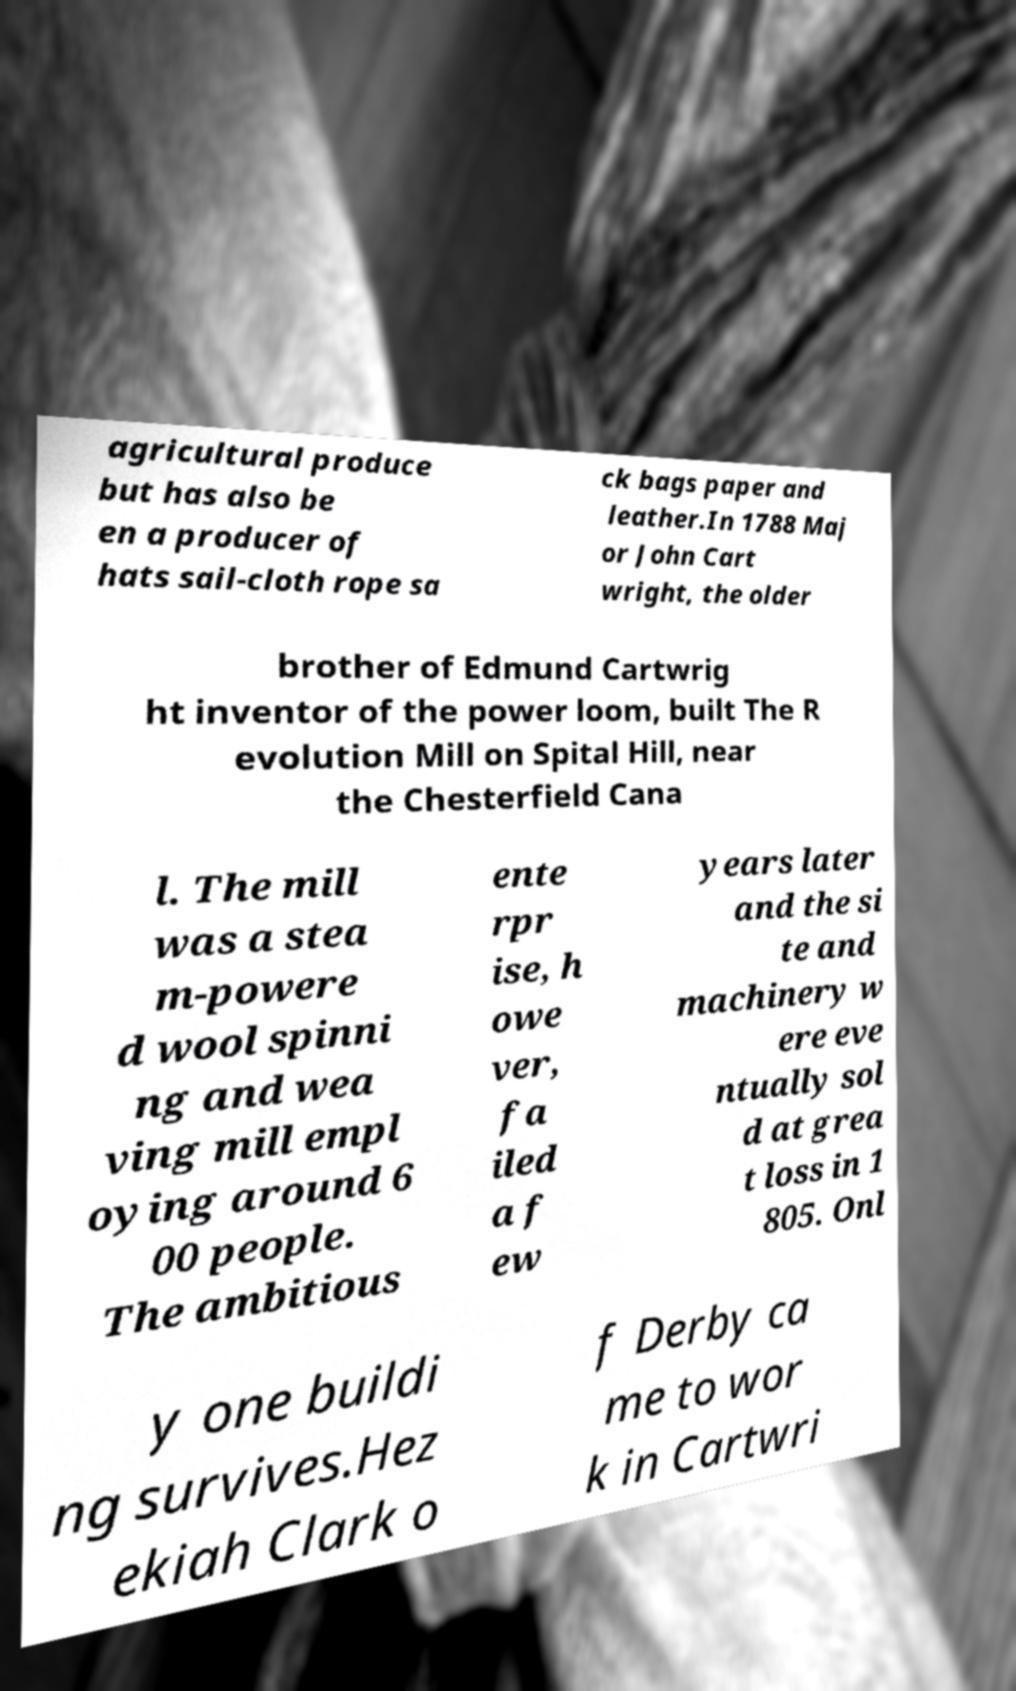For documentation purposes, I need the text within this image transcribed. Could you provide that? agricultural produce but has also be en a producer of hats sail-cloth rope sa ck bags paper and leather.In 1788 Maj or John Cart wright, the older brother of Edmund Cartwrig ht inventor of the power loom, built The R evolution Mill on Spital Hill, near the Chesterfield Cana l. The mill was a stea m-powere d wool spinni ng and wea ving mill empl oying around 6 00 people. The ambitious ente rpr ise, h owe ver, fa iled a f ew years later and the si te and machinery w ere eve ntually sol d at grea t loss in 1 805. Onl y one buildi ng survives.Hez ekiah Clark o f Derby ca me to wor k in Cartwri 